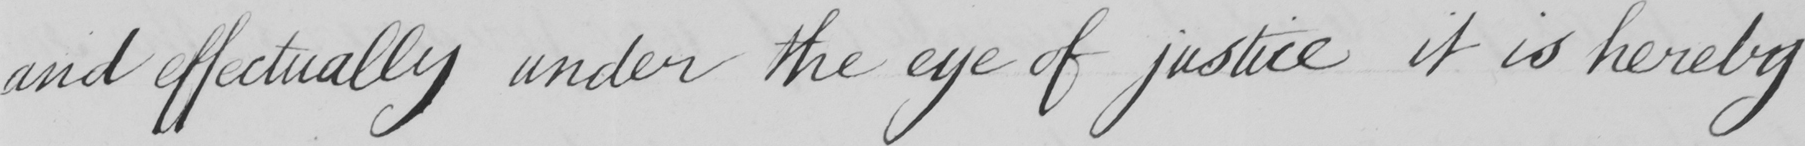Transcribe the text shown in this historical manuscript line. and effectually under the eye of justice it is hereby 